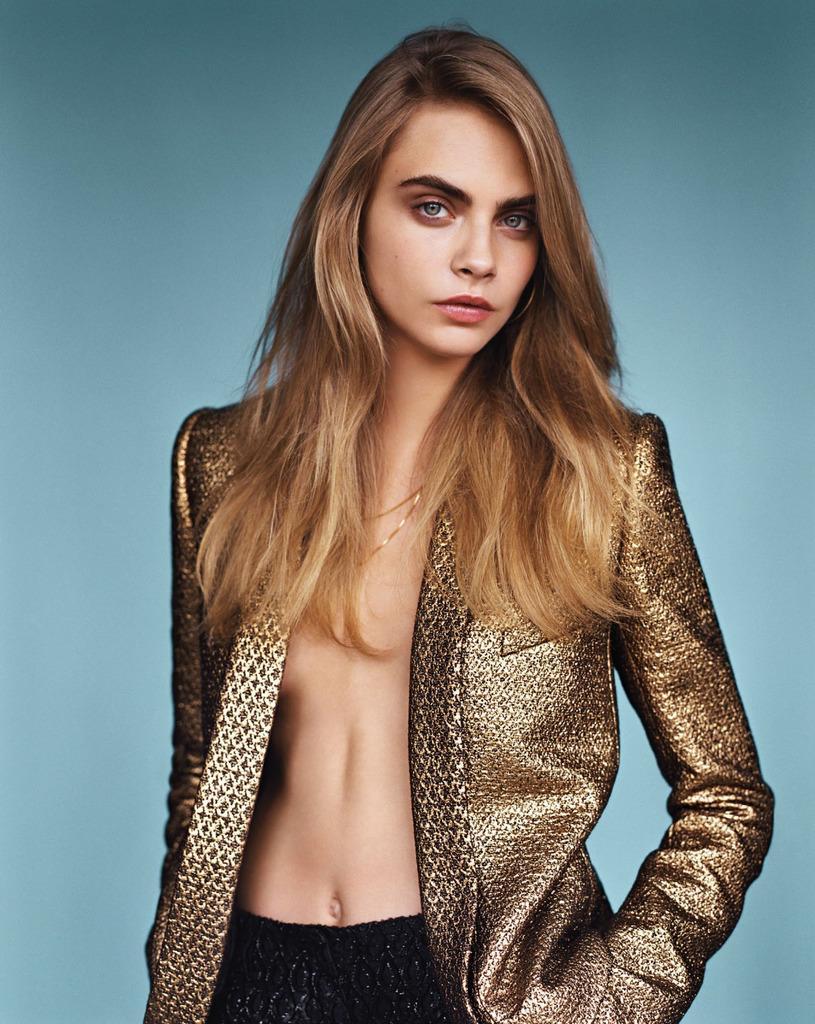Describe this image in one or two sentences. In this picture we can see a beautiful woman wearing a jacket and she is giving a pose. 